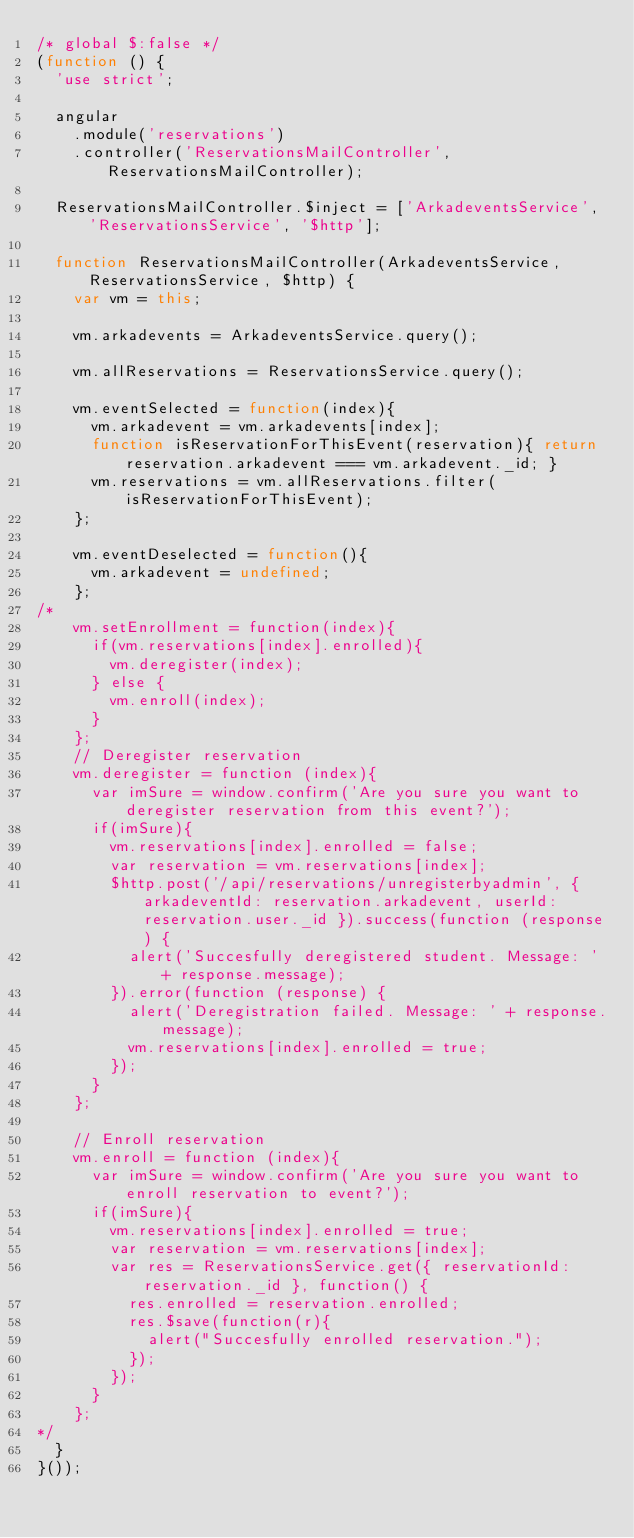Convert code to text. <code><loc_0><loc_0><loc_500><loc_500><_JavaScript_>/* global $:false */
(function () {
  'use strict';

  angular
    .module('reservations')
    .controller('ReservationsMailController', ReservationsMailController);

  ReservationsMailController.$inject = ['ArkadeventsService', 'ReservationsService', '$http'];

  function ReservationsMailController(ArkadeventsService, ReservationsService, $http) {
    var vm = this;

    vm.arkadevents = ArkadeventsService.query();

    vm.allReservations = ReservationsService.query();

    vm.eventSelected = function(index){
      vm.arkadevent = vm.arkadevents[index];
      function isReservationForThisEvent(reservation){ return reservation.arkadevent === vm.arkadevent._id; }
      vm.reservations = vm.allReservations.filter(isReservationForThisEvent);
    };

    vm.eventDeselected = function(){
      vm.arkadevent = undefined;
    };
/*
    vm.setEnrollment = function(index){
      if(vm.reservations[index].enrolled){
        vm.deregister(index);
      } else {
        vm.enroll(index);
      }
    };
    // Deregister reservation
    vm.deregister = function (index){
      var imSure = window.confirm('Are you sure you want to deregister reservation from this event?');
      if(imSure){
        vm.reservations[index].enrolled = false;
        var reservation = vm.reservations[index];
        $http.post('/api/reservations/unregisterbyadmin', { arkadeventId: reservation.arkadevent, userId: reservation.user._id }).success(function (response) {
          alert('Succesfully deregistered student. Message: ' + response.message);
        }).error(function (response) {
          alert('Deregistration failed. Message: ' + response.message);
          vm.reservations[index].enrolled = true;
        });
      }
    };
  
    // Enroll reservation
    vm.enroll = function (index){
      var imSure = window.confirm('Are you sure you want to enroll reservation to event?');
      if(imSure){
        vm.reservations[index].enrolled = true;
        var reservation = vm.reservations[index];
        var res = ReservationsService.get({ reservationId: reservation._id }, function() {
          res.enrolled = reservation.enrolled;
          res.$save(function(r){
            alert("Succesfully enrolled reservation.");
          });
        });
      }
    };
*/
  }
}());
</code> 